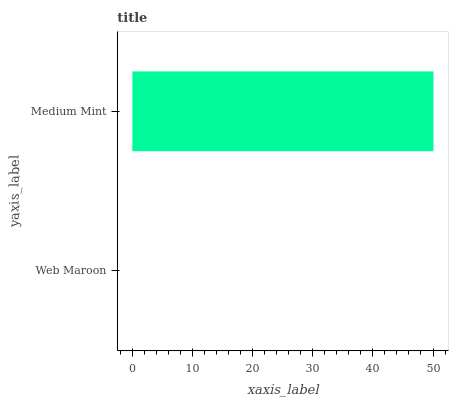Is Web Maroon the minimum?
Answer yes or no. Yes. Is Medium Mint the maximum?
Answer yes or no. Yes. Is Medium Mint the minimum?
Answer yes or no. No. Is Medium Mint greater than Web Maroon?
Answer yes or no. Yes. Is Web Maroon less than Medium Mint?
Answer yes or no. Yes. Is Web Maroon greater than Medium Mint?
Answer yes or no. No. Is Medium Mint less than Web Maroon?
Answer yes or no. No. Is Medium Mint the high median?
Answer yes or no. Yes. Is Web Maroon the low median?
Answer yes or no. Yes. Is Web Maroon the high median?
Answer yes or no. No. Is Medium Mint the low median?
Answer yes or no. No. 